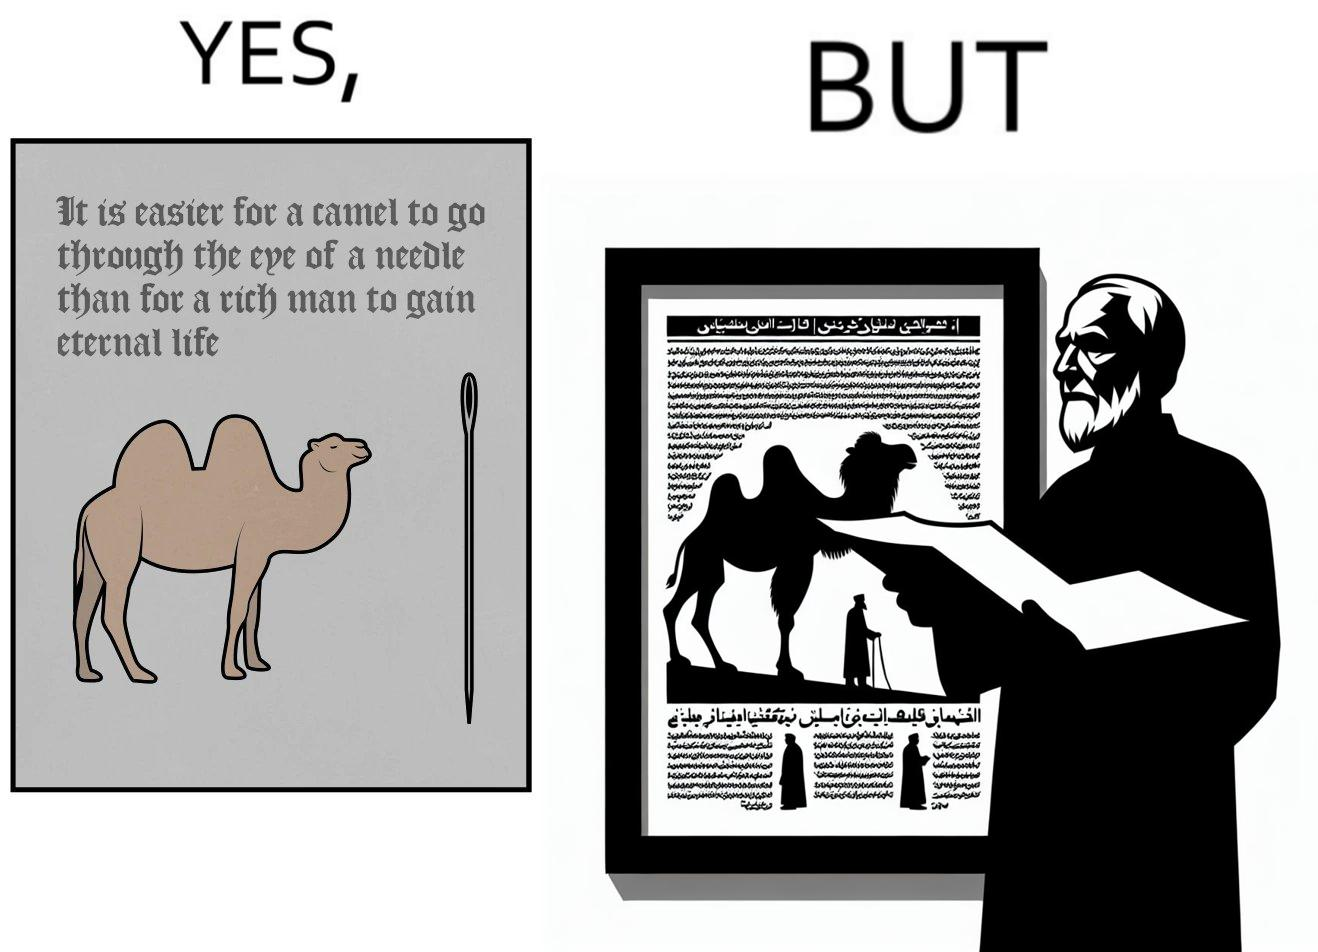Compare the left and right sides of this image. In the left part of the image: a bactrian camel(two humped camel) is seen with a needle of its height in front of it and a quote written above the image In the right part of the image: a saintly old man is shown holding some poster with some writings on it with a photo of a bactrian camel(two humped camel) 